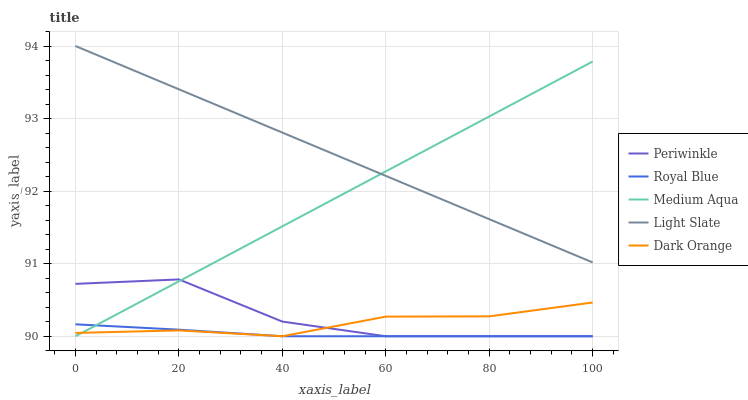Does Periwinkle have the minimum area under the curve?
Answer yes or no. No. Does Periwinkle have the maximum area under the curve?
Answer yes or no. No. Is Royal Blue the smoothest?
Answer yes or no. No. Is Royal Blue the roughest?
Answer yes or no. No. Does Light Slate have the lowest value?
Answer yes or no. No. Does Periwinkle have the highest value?
Answer yes or no. No. Is Periwinkle less than Light Slate?
Answer yes or no. Yes. Is Light Slate greater than Dark Orange?
Answer yes or no. Yes. Does Periwinkle intersect Light Slate?
Answer yes or no. No. 